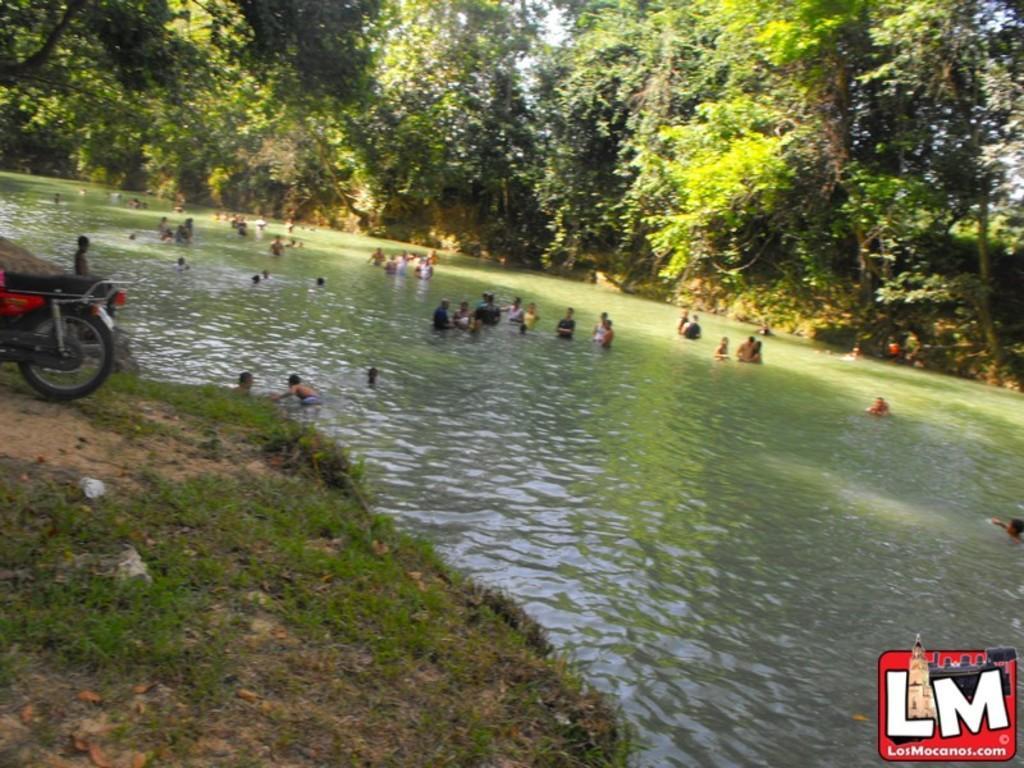How would you summarize this image in a sentence or two? In this image, we can see people in the water and in the background, there are trees and we can see a bike and there is ground and logo. 